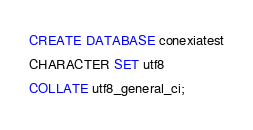Convert code to text. <code><loc_0><loc_0><loc_500><loc_500><_SQL_>CREATE DATABASE conexiatest
CHARACTER SET utf8
COLLATE utf8_general_ci;</code> 